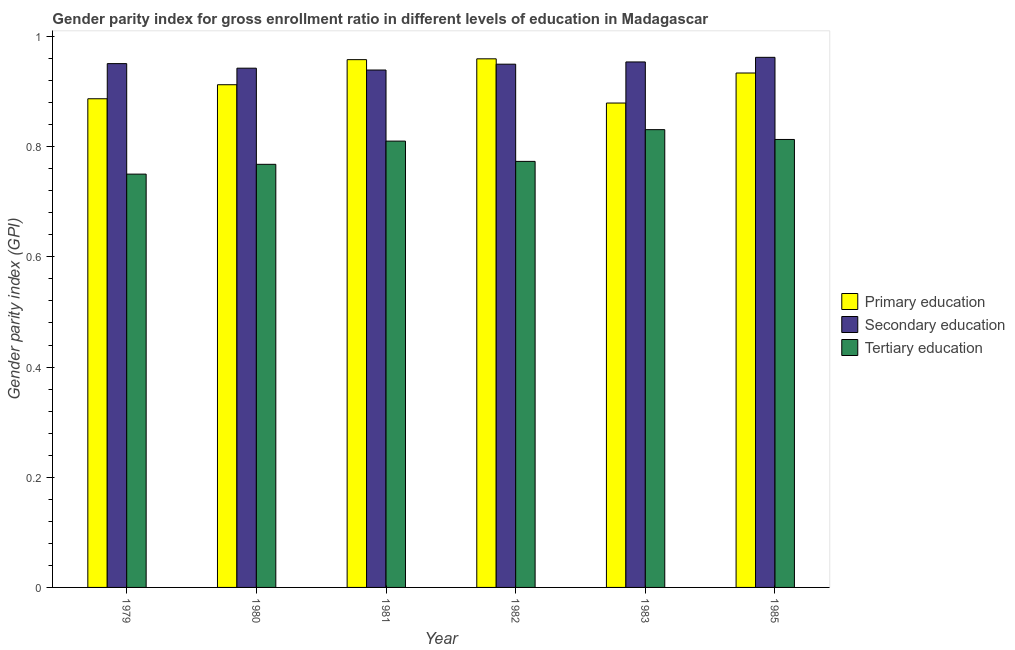How many different coloured bars are there?
Provide a succinct answer. 3. How many groups of bars are there?
Make the answer very short. 6. Are the number of bars per tick equal to the number of legend labels?
Your answer should be compact. Yes. What is the label of the 5th group of bars from the left?
Give a very brief answer. 1983. In how many cases, is the number of bars for a given year not equal to the number of legend labels?
Offer a very short reply. 0. What is the gender parity index in secondary education in 1982?
Provide a short and direct response. 0.95. Across all years, what is the maximum gender parity index in tertiary education?
Offer a very short reply. 0.83. Across all years, what is the minimum gender parity index in secondary education?
Make the answer very short. 0.94. In which year was the gender parity index in primary education maximum?
Your response must be concise. 1982. In which year was the gender parity index in tertiary education minimum?
Make the answer very short. 1979. What is the total gender parity index in tertiary education in the graph?
Keep it short and to the point. 4.75. What is the difference between the gender parity index in tertiary education in 1979 and that in 1982?
Give a very brief answer. -0.02. What is the difference between the gender parity index in primary education in 1982 and the gender parity index in secondary education in 1981?
Offer a very short reply. 0. What is the average gender parity index in secondary education per year?
Provide a short and direct response. 0.95. What is the ratio of the gender parity index in secondary education in 1980 to that in 1982?
Your answer should be very brief. 0.99. Is the gender parity index in primary education in 1979 less than that in 1985?
Provide a succinct answer. Yes. What is the difference between the highest and the second highest gender parity index in secondary education?
Provide a short and direct response. 0.01. What is the difference between the highest and the lowest gender parity index in primary education?
Your answer should be compact. 0.08. In how many years, is the gender parity index in tertiary education greater than the average gender parity index in tertiary education taken over all years?
Make the answer very short. 3. What does the 1st bar from the left in 1982 represents?
Your answer should be compact. Primary education. What does the 1st bar from the right in 1981 represents?
Provide a short and direct response. Tertiary education. How many bars are there?
Make the answer very short. 18. How many years are there in the graph?
Offer a terse response. 6. What is the difference between two consecutive major ticks on the Y-axis?
Offer a very short reply. 0.2. Does the graph contain grids?
Give a very brief answer. No. Where does the legend appear in the graph?
Your response must be concise. Center right. What is the title of the graph?
Give a very brief answer. Gender parity index for gross enrollment ratio in different levels of education in Madagascar. Does "Tertiary" appear as one of the legend labels in the graph?
Offer a very short reply. No. What is the label or title of the X-axis?
Make the answer very short. Year. What is the label or title of the Y-axis?
Make the answer very short. Gender parity index (GPI). What is the Gender parity index (GPI) of Primary education in 1979?
Provide a short and direct response. 0.89. What is the Gender parity index (GPI) in Secondary education in 1979?
Give a very brief answer. 0.95. What is the Gender parity index (GPI) in Tertiary education in 1979?
Provide a short and direct response. 0.75. What is the Gender parity index (GPI) of Primary education in 1980?
Provide a succinct answer. 0.91. What is the Gender parity index (GPI) of Secondary education in 1980?
Provide a succinct answer. 0.94. What is the Gender parity index (GPI) of Tertiary education in 1980?
Provide a short and direct response. 0.77. What is the Gender parity index (GPI) of Primary education in 1981?
Provide a short and direct response. 0.96. What is the Gender parity index (GPI) in Secondary education in 1981?
Your response must be concise. 0.94. What is the Gender parity index (GPI) in Tertiary education in 1981?
Offer a terse response. 0.81. What is the Gender parity index (GPI) of Primary education in 1982?
Make the answer very short. 0.96. What is the Gender parity index (GPI) of Secondary education in 1982?
Your answer should be compact. 0.95. What is the Gender parity index (GPI) of Tertiary education in 1982?
Make the answer very short. 0.77. What is the Gender parity index (GPI) of Primary education in 1983?
Ensure brevity in your answer.  0.88. What is the Gender parity index (GPI) of Secondary education in 1983?
Ensure brevity in your answer.  0.95. What is the Gender parity index (GPI) in Tertiary education in 1983?
Your response must be concise. 0.83. What is the Gender parity index (GPI) in Primary education in 1985?
Keep it short and to the point. 0.93. What is the Gender parity index (GPI) of Secondary education in 1985?
Ensure brevity in your answer.  0.96. What is the Gender parity index (GPI) of Tertiary education in 1985?
Your response must be concise. 0.81. Across all years, what is the maximum Gender parity index (GPI) of Primary education?
Your answer should be compact. 0.96. Across all years, what is the maximum Gender parity index (GPI) of Secondary education?
Make the answer very short. 0.96. Across all years, what is the maximum Gender parity index (GPI) of Tertiary education?
Provide a succinct answer. 0.83. Across all years, what is the minimum Gender parity index (GPI) of Primary education?
Offer a terse response. 0.88. Across all years, what is the minimum Gender parity index (GPI) in Secondary education?
Keep it short and to the point. 0.94. Across all years, what is the minimum Gender parity index (GPI) in Tertiary education?
Your answer should be very brief. 0.75. What is the total Gender parity index (GPI) of Primary education in the graph?
Provide a short and direct response. 5.53. What is the total Gender parity index (GPI) in Secondary education in the graph?
Offer a terse response. 5.7. What is the total Gender parity index (GPI) in Tertiary education in the graph?
Your answer should be very brief. 4.75. What is the difference between the Gender parity index (GPI) in Primary education in 1979 and that in 1980?
Offer a terse response. -0.03. What is the difference between the Gender parity index (GPI) in Secondary education in 1979 and that in 1980?
Provide a short and direct response. 0.01. What is the difference between the Gender parity index (GPI) in Tertiary education in 1979 and that in 1980?
Ensure brevity in your answer.  -0.02. What is the difference between the Gender parity index (GPI) of Primary education in 1979 and that in 1981?
Your answer should be compact. -0.07. What is the difference between the Gender parity index (GPI) in Secondary education in 1979 and that in 1981?
Provide a short and direct response. 0.01. What is the difference between the Gender parity index (GPI) of Tertiary education in 1979 and that in 1981?
Your response must be concise. -0.06. What is the difference between the Gender parity index (GPI) of Primary education in 1979 and that in 1982?
Your response must be concise. -0.07. What is the difference between the Gender parity index (GPI) in Secondary education in 1979 and that in 1982?
Make the answer very short. 0. What is the difference between the Gender parity index (GPI) of Tertiary education in 1979 and that in 1982?
Offer a very short reply. -0.02. What is the difference between the Gender parity index (GPI) of Primary education in 1979 and that in 1983?
Offer a terse response. 0.01. What is the difference between the Gender parity index (GPI) of Secondary education in 1979 and that in 1983?
Offer a terse response. -0. What is the difference between the Gender parity index (GPI) of Tertiary education in 1979 and that in 1983?
Your answer should be compact. -0.08. What is the difference between the Gender parity index (GPI) in Primary education in 1979 and that in 1985?
Offer a very short reply. -0.05. What is the difference between the Gender parity index (GPI) in Secondary education in 1979 and that in 1985?
Offer a terse response. -0.01. What is the difference between the Gender parity index (GPI) of Tertiary education in 1979 and that in 1985?
Your answer should be compact. -0.06. What is the difference between the Gender parity index (GPI) of Primary education in 1980 and that in 1981?
Make the answer very short. -0.05. What is the difference between the Gender parity index (GPI) in Secondary education in 1980 and that in 1981?
Make the answer very short. 0. What is the difference between the Gender parity index (GPI) in Tertiary education in 1980 and that in 1981?
Offer a very short reply. -0.04. What is the difference between the Gender parity index (GPI) in Primary education in 1980 and that in 1982?
Give a very brief answer. -0.05. What is the difference between the Gender parity index (GPI) of Secondary education in 1980 and that in 1982?
Keep it short and to the point. -0.01. What is the difference between the Gender parity index (GPI) in Tertiary education in 1980 and that in 1982?
Make the answer very short. -0.01. What is the difference between the Gender parity index (GPI) in Primary education in 1980 and that in 1983?
Offer a terse response. 0.03. What is the difference between the Gender parity index (GPI) of Secondary education in 1980 and that in 1983?
Give a very brief answer. -0.01. What is the difference between the Gender parity index (GPI) in Tertiary education in 1980 and that in 1983?
Provide a succinct answer. -0.06. What is the difference between the Gender parity index (GPI) in Primary education in 1980 and that in 1985?
Your answer should be very brief. -0.02. What is the difference between the Gender parity index (GPI) in Secondary education in 1980 and that in 1985?
Your answer should be very brief. -0.02. What is the difference between the Gender parity index (GPI) of Tertiary education in 1980 and that in 1985?
Your answer should be very brief. -0.05. What is the difference between the Gender parity index (GPI) of Primary education in 1981 and that in 1982?
Provide a succinct answer. -0. What is the difference between the Gender parity index (GPI) in Secondary education in 1981 and that in 1982?
Provide a succinct answer. -0.01. What is the difference between the Gender parity index (GPI) of Tertiary education in 1981 and that in 1982?
Make the answer very short. 0.04. What is the difference between the Gender parity index (GPI) in Primary education in 1981 and that in 1983?
Your answer should be compact. 0.08. What is the difference between the Gender parity index (GPI) in Secondary education in 1981 and that in 1983?
Your answer should be compact. -0.01. What is the difference between the Gender parity index (GPI) in Tertiary education in 1981 and that in 1983?
Provide a short and direct response. -0.02. What is the difference between the Gender parity index (GPI) of Primary education in 1981 and that in 1985?
Offer a terse response. 0.02. What is the difference between the Gender parity index (GPI) in Secondary education in 1981 and that in 1985?
Your response must be concise. -0.02. What is the difference between the Gender parity index (GPI) of Tertiary education in 1981 and that in 1985?
Ensure brevity in your answer.  -0. What is the difference between the Gender parity index (GPI) of Primary education in 1982 and that in 1983?
Offer a terse response. 0.08. What is the difference between the Gender parity index (GPI) in Secondary education in 1982 and that in 1983?
Your answer should be very brief. -0. What is the difference between the Gender parity index (GPI) in Tertiary education in 1982 and that in 1983?
Your response must be concise. -0.06. What is the difference between the Gender parity index (GPI) in Primary education in 1982 and that in 1985?
Offer a very short reply. 0.03. What is the difference between the Gender parity index (GPI) in Secondary education in 1982 and that in 1985?
Offer a very short reply. -0.01. What is the difference between the Gender parity index (GPI) in Tertiary education in 1982 and that in 1985?
Provide a short and direct response. -0.04. What is the difference between the Gender parity index (GPI) in Primary education in 1983 and that in 1985?
Give a very brief answer. -0.05. What is the difference between the Gender parity index (GPI) in Secondary education in 1983 and that in 1985?
Offer a very short reply. -0.01. What is the difference between the Gender parity index (GPI) in Tertiary education in 1983 and that in 1985?
Provide a succinct answer. 0.02. What is the difference between the Gender parity index (GPI) in Primary education in 1979 and the Gender parity index (GPI) in Secondary education in 1980?
Your response must be concise. -0.06. What is the difference between the Gender parity index (GPI) of Primary education in 1979 and the Gender parity index (GPI) of Tertiary education in 1980?
Offer a terse response. 0.12. What is the difference between the Gender parity index (GPI) of Secondary education in 1979 and the Gender parity index (GPI) of Tertiary education in 1980?
Provide a short and direct response. 0.18. What is the difference between the Gender parity index (GPI) in Primary education in 1979 and the Gender parity index (GPI) in Secondary education in 1981?
Make the answer very short. -0.05. What is the difference between the Gender parity index (GPI) of Primary education in 1979 and the Gender parity index (GPI) of Tertiary education in 1981?
Offer a very short reply. 0.08. What is the difference between the Gender parity index (GPI) of Secondary education in 1979 and the Gender parity index (GPI) of Tertiary education in 1981?
Your answer should be compact. 0.14. What is the difference between the Gender parity index (GPI) of Primary education in 1979 and the Gender parity index (GPI) of Secondary education in 1982?
Give a very brief answer. -0.06. What is the difference between the Gender parity index (GPI) in Primary education in 1979 and the Gender parity index (GPI) in Tertiary education in 1982?
Offer a terse response. 0.11. What is the difference between the Gender parity index (GPI) in Secondary education in 1979 and the Gender parity index (GPI) in Tertiary education in 1982?
Make the answer very short. 0.18. What is the difference between the Gender parity index (GPI) of Primary education in 1979 and the Gender parity index (GPI) of Secondary education in 1983?
Provide a short and direct response. -0.07. What is the difference between the Gender parity index (GPI) in Primary education in 1979 and the Gender parity index (GPI) in Tertiary education in 1983?
Offer a very short reply. 0.06. What is the difference between the Gender parity index (GPI) of Secondary education in 1979 and the Gender parity index (GPI) of Tertiary education in 1983?
Your answer should be compact. 0.12. What is the difference between the Gender parity index (GPI) in Primary education in 1979 and the Gender parity index (GPI) in Secondary education in 1985?
Your response must be concise. -0.08. What is the difference between the Gender parity index (GPI) of Primary education in 1979 and the Gender parity index (GPI) of Tertiary education in 1985?
Make the answer very short. 0.07. What is the difference between the Gender parity index (GPI) in Secondary education in 1979 and the Gender parity index (GPI) in Tertiary education in 1985?
Offer a very short reply. 0.14. What is the difference between the Gender parity index (GPI) of Primary education in 1980 and the Gender parity index (GPI) of Secondary education in 1981?
Your answer should be very brief. -0.03. What is the difference between the Gender parity index (GPI) in Primary education in 1980 and the Gender parity index (GPI) in Tertiary education in 1981?
Ensure brevity in your answer.  0.1. What is the difference between the Gender parity index (GPI) of Secondary education in 1980 and the Gender parity index (GPI) of Tertiary education in 1981?
Make the answer very short. 0.13. What is the difference between the Gender parity index (GPI) in Primary education in 1980 and the Gender parity index (GPI) in Secondary education in 1982?
Make the answer very short. -0.04. What is the difference between the Gender parity index (GPI) of Primary education in 1980 and the Gender parity index (GPI) of Tertiary education in 1982?
Make the answer very short. 0.14. What is the difference between the Gender parity index (GPI) in Secondary education in 1980 and the Gender parity index (GPI) in Tertiary education in 1982?
Make the answer very short. 0.17. What is the difference between the Gender parity index (GPI) in Primary education in 1980 and the Gender parity index (GPI) in Secondary education in 1983?
Keep it short and to the point. -0.04. What is the difference between the Gender parity index (GPI) in Primary education in 1980 and the Gender parity index (GPI) in Tertiary education in 1983?
Provide a short and direct response. 0.08. What is the difference between the Gender parity index (GPI) in Secondary education in 1980 and the Gender parity index (GPI) in Tertiary education in 1983?
Your answer should be compact. 0.11. What is the difference between the Gender parity index (GPI) in Primary education in 1980 and the Gender parity index (GPI) in Secondary education in 1985?
Offer a terse response. -0.05. What is the difference between the Gender parity index (GPI) of Primary education in 1980 and the Gender parity index (GPI) of Tertiary education in 1985?
Provide a short and direct response. 0.1. What is the difference between the Gender parity index (GPI) in Secondary education in 1980 and the Gender parity index (GPI) in Tertiary education in 1985?
Offer a very short reply. 0.13. What is the difference between the Gender parity index (GPI) of Primary education in 1981 and the Gender parity index (GPI) of Secondary education in 1982?
Keep it short and to the point. 0.01. What is the difference between the Gender parity index (GPI) in Primary education in 1981 and the Gender parity index (GPI) in Tertiary education in 1982?
Offer a very short reply. 0.18. What is the difference between the Gender parity index (GPI) in Secondary education in 1981 and the Gender parity index (GPI) in Tertiary education in 1982?
Ensure brevity in your answer.  0.17. What is the difference between the Gender parity index (GPI) in Primary education in 1981 and the Gender parity index (GPI) in Secondary education in 1983?
Your answer should be compact. 0. What is the difference between the Gender parity index (GPI) in Primary education in 1981 and the Gender parity index (GPI) in Tertiary education in 1983?
Your answer should be very brief. 0.13. What is the difference between the Gender parity index (GPI) of Secondary education in 1981 and the Gender parity index (GPI) of Tertiary education in 1983?
Provide a short and direct response. 0.11. What is the difference between the Gender parity index (GPI) in Primary education in 1981 and the Gender parity index (GPI) in Secondary education in 1985?
Provide a succinct answer. -0. What is the difference between the Gender parity index (GPI) in Primary education in 1981 and the Gender parity index (GPI) in Tertiary education in 1985?
Your answer should be very brief. 0.14. What is the difference between the Gender parity index (GPI) of Secondary education in 1981 and the Gender parity index (GPI) of Tertiary education in 1985?
Your answer should be compact. 0.13. What is the difference between the Gender parity index (GPI) of Primary education in 1982 and the Gender parity index (GPI) of Secondary education in 1983?
Provide a succinct answer. 0.01. What is the difference between the Gender parity index (GPI) of Primary education in 1982 and the Gender parity index (GPI) of Tertiary education in 1983?
Your response must be concise. 0.13. What is the difference between the Gender parity index (GPI) of Secondary education in 1982 and the Gender parity index (GPI) of Tertiary education in 1983?
Make the answer very short. 0.12. What is the difference between the Gender parity index (GPI) in Primary education in 1982 and the Gender parity index (GPI) in Secondary education in 1985?
Keep it short and to the point. -0. What is the difference between the Gender parity index (GPI) of Primary education in 1982 and the Gender parity index (GPI) of Tertiary education in 1985?
Offer a terse response. 0.15. What is the difference between the Gender parity index (GPI) in Secondary education in 1982 and the Gender parity index (GPI) in Tertiary education in 1985?
Keep it short and to the point. 0.14. What is the difference between the Gender parity index (GPI) in Primary education in 1983 and the Gender parity index (GPI) in Secondary education in 1985?
Your answer should be very brief. -0.08. What is the difference between the Gender parity index (GPI) of Primary education in 1983 and the Gender parity index (GPI) of Tertiary education in 1985?
Make the answer very short. 0.07. What is the difference between the Gender parity index (GPI) of Secondary education in 1983 and the Gender parity index (GPI) of Tertiary education in 1985?
Keep it short and to the point. 0.14. What is the average Gender parity index (GPI) of Primary education per year?
Make the answer very short. 0.92. What is the average Gender parity index (GPI) in Secondary education per year?
Give a very brief answer. 0.95. What is the average Gender parity index (GPI) in Tertiary education per year?
Your response must be concise. 0.79. In the year 1979, what is the difference between the Gender parity index (GPI) of Primary education and Gender parity index (GPI) of Secondary education?
Make the answer very short. -0.06. In the year 1979, what is the difference between the Gender parity index (GPI) in Primary education and Gender parity index (GPI) in Tertiary education?
Your response must be concise. 0.14. In the year 1979, what is the difference between the Gender parity index (GPI) of Secondary education and Gender parity index (GPI) of Tertiary education?
Your response must be concise. 0.2. In the year 1980, what is the difference between the Gender parity index (GPI) in Primary education and Gender parity index (GPI) in Secondary education?
Your response must be concise. -0.03. In the year 1980, what is the difference between the Gender parity index (GPI) in Primary education and Gender parity index (GPI) in Tertiary education?
Make the answer very short. 0.14. In the year 1980, what is the difference between the Gender parity index (GPI) of Secondary education and Gender parity index (GPI) of Tertiary education?
Offer a terse response. 0.17. In the year 1981, what is the difference between the Gender parity index (GPI) of Primary education and Gender parity index (GPI) of Secondary education?
Ensure brevity in your answer.  0.02. In the year 1981, what is the difference between the Gender parity index (GPI) in Primary education and Gender parity index (GPI) in Tertiary education?
Offer a terse response. 0.15. In the year 1981, what is the difference between the Gender parity index (GPI) of Secondary education and Gender parity index (GPI) of Tertiary education?
Provide a succinct answer. 0.13. In the year 1982, what is the difference between the Gender parity index (GPI) in Primary education and Gender parity index (GPI) in Secondary education?
Keep it short and to the point. 0.01. In the year 1982, what is the difference between the Gender parity index (GPI) of Primary education and Gender parity index (GPI) of Tertiary education?
Make the answer very short. 0.19. In the year 1982, what is the difference between the Gender parity index (GPI) in Secondary education and Gender parity index (GPI) in Tertiary education?
Offer a very short reply. 0.18. In the year 1983, what is the difference between the Gender parity index (GPI) in Primary education and Gender parity index (GPI) in Secondary education?
Give a very brief answer. -0.07. In the year 1983, what is the difference between the Gender parity index (GPI) of Primary education and Gender parity index (GPI) of Tertiary education?
Ensure brevity in your answer.  0.05. In the year 1983, what is the difference between the Gender parity index (GPI) in Secondary education and Gender parity index (GPI) in Tertiary education?
Offer a very short reply. 0.12. In the year 1985, what is the difference between the Gender parity index (GPI) of Primary education and Gender parity index (GPI) of Secondary education?
Offer a very short reply. -0.03. In the year 1985, what is the difference between the Gender parity index (GPI) of Primary education and Gender parity index (GPI) of Tertiary education?
Provide a short and direct response. 0.12. In the year 1985, what is the difference between the Gender parity index (GPI) in Secondary education and Gender parity index (GPI) in Tertiary education?
Your answer should be very brief. 0.15. What is the ratio of the Gender parity index (GPI) in Primary education in 1979 to that in 1980?
Offer a very short reply. 0.97. What is the ratio of the Gender parity index (GPI) of Secondary education in 1979 to that in 1980?
Make the answer very short. 1.01. What is the ratio of the Gender parity index (GPI) of Tertiary education in 1979 to that in 1980?
Keep it short and to the point. 0.98. What is the ratio of the Gender parity index (GPI) of Primary education in 1979 to that in 1981?
Keep it short and to the point. 0.93. What is the ratio of the Gender parity index (GPI) of Secondary education in 1979 to that in 1981?
Your answer should be compact. 1.01. What is the ratio of the Gender parity index (GPI) of Tertiary education in 1979 to that in 1981?
Provide a succinct answer. 0.93. What is the ratio of the Gender parity index (GPI) in Primary education in 1979 to that in 1982?
Make the answer very short. 0.92. What is the ratio of the Gender parity index (GPI) of Tertiary education in 1979 to that in 1982?
Ensure brevity in your answer.  0.97. What is the ratio of the Gender parity index (GPI) of Primary education in 1979 to that in 1983?
Provide a succinct answer. 1.01. What is the ratio of the Gender parity index (GPI) in Secondary education in 1979 to that in 1983?
Offer a very short reply. 1. What is the ratio of the Gender parity index (GPI) of Tertiary education in 1979 to that in 1983?
Give a very brief answer. 0.9. What is the ratio of the Gender parity index (GPI) in Primary education in 1979 to that in 1985?
Your answer should be very brief. 0.95. What is the ratio of the Gender parity index (GPI) of Secondary education in 1979 to that in 1985?
Make the answer very short. 0.99. What is the ratio of the Gender parity index (GPI) of Tertiary education in 1979 to that in 1985?
Keep it short and to the point. 0.92. What is the ratio of the Gender parity index (GPI) in Primary education in 1980 to that in 1981?
Your response must be concise. 0.95. What is the ratio of the Gender parity index (GPI) in Tertiary education in 1980 to that in 1981?
Your answer should be compact. 0.95. What is the ratio of the Gender parity index (GPI) in Primary education in 1980 to that in 1982?
Offer a very short reply. 0.95. What is the ratio of the Gender parity index (GPI) of Secondary education in 1980 to that in 1982?
Your answer should be compact. 0.99. What is the ratio of the Gender parity index (GPI) in Tertiary education in 1980 to that in 1982?
Your answer should be compact. 0.99. What is the ratio of the Gender parity index (GPI) in Primary education in 1980 to that in 1983?
Offer a very short reply. 1.04. What is the ratio of the Gender parity index (GPI) of Tertiary education in 1980 to that in 1983?
Keep it short and to the point. 0.92. What is the ratio of the Gender parity index (GPI) in Primary education in 1980 to that in 1985?
Ensure brevity in your answer.  0.98. What is the ratio of the Gender parity index (GPI) in Secondary education in 1980 to that in 1985?
Give a very brief answer. 0.98. What is the ratio of the Gender parity index (GPI) in Tertiary education in 1980 to that in 1985?
Offer a very short reply. 0.94. What is the ratio of the Gender parity index (GPI) of Primary education in 1981 to that in 1982?
Offer a terse response. 1. What is the ratio of the Gender parity index (GPI) in Secondary education in 1981 to that in 1982?
Your response must be concise. 0.99. What is the ratio of the Gender parity index (GPI) of Tertiary education in 1981 to that in 1982?
Provide a succinct answer. 1.05. What is the ratio of the Gender parity index (GPI) in Primary education in 1981 to that in 1983?
Keep it short and to the point. 1.09. What is the ratio of the Gender parity index (GPI) in Secondary education in 1981 to that in 1983?
Provide a short and direct response. 0.98. What is the ratio of the Gender parity index (GPI) of Secondary education in 1981 to that in 1985?
Your answer should be very brief. 0.98. What is the ratio of the Gender parity index (GPI) in Tertiary education in 1981 to that in 1985?
Ensure brevity in your answer.  1. What is the ratio of the Gender parity index (GPI) in Primary education in 1982 to that in 1983?
Give a very brief answer. 1.09. What is the ratio of the Gender parity index (GPI) of Secondary education in 1982 to that in 1983?
Give a very brief answer. 1. What is the ratio of the Gender parity index (GPI) of Tertiary education in 1982 to that in 1983?
Make the answer very short. 0.93. What is the ratio of the Gender parity index (GPI) in Primary education in 1982 to that in 1985?
Keep it short and to the point. 1.03. What is the ratio of the Gender parity index (GPI) of Secondary education in 1982 to that in 1985?
Provide a short and direct response. 0.99. What is the ratio of the Gender parity index (GPI) in Tertiary education in 1982 to that in 1985?
Offer a terse response. 0.95. What is the ratio of the Gender parity index (GPI) of Primary education in 1983 to that in 1985?
Keep it short and to the point. 0.94. What is the ratio of the Gender parity index (GPI) of Tertiary education in 1983 to that in 1985?
Offer a very short reply. 1.02. What is the difference between the highest and the second highest Gender parity index (GPI) in Primary education?
Your response must be concise. 0. What is the difference between the highest and the second highest Gender parity index (GPI) of Secondary education?
Your response must be concise. 0.01. What is the difference between the highest and the second highest Gender parity index (GPI) in Tertiary education?
Your answer should be very brief. 0.02. What is the difference between the highest and the lowest Gender parity index (GPI) in Primary education?
Offer a terse response. 0.08. What is the difference between the highest and the lowest Gender parity index (GPI) in Secondary education?
Your response must be concise. 0.02. What is the difference between the highest and the lowest Gender parity index (GPI) of Tertiary education?
Give a very brief answer. 0.08. 